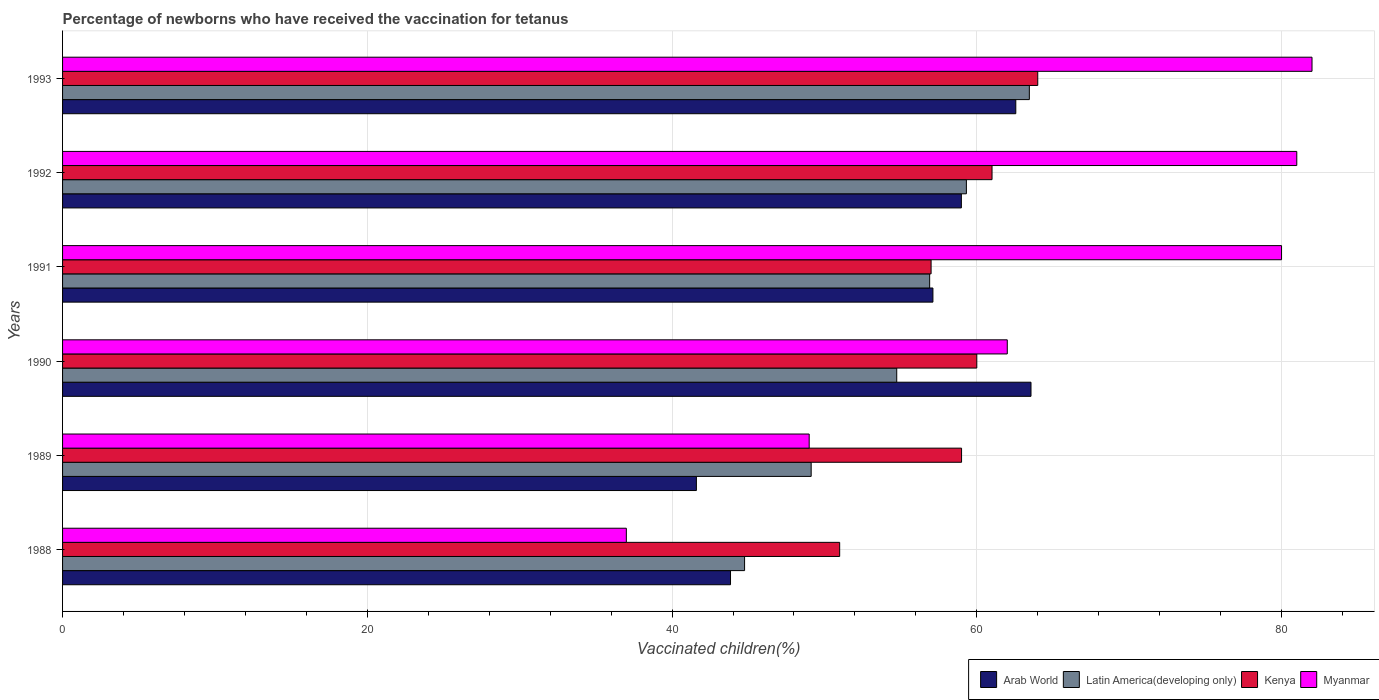How many different coloured bars are there?
Provide a succinct answer. 4. How many groups of bars are there?
Keep it short and to the point. 6. Are the number of bars per tick equal to the number of legend labels?
Offer a very short reply. Yes. Are the number of bars on each tick of the Y-axis equal?
Offer a terse response. Yes. How many bars are there on the 1st tick from the top?
Offer a terse response. 4. What is the label of the 3rd group of bars from the top?
Make the answer very short. 1991. What is the percentage of vaccinated children in Latin America(developing only) in 1988?
Keep it short and to the point. 44.76. Across all years, what is the maximum percentage of vaccinated children in Latin America(developing only)?
Ensure brevity in your answer.  63.45. Across all years, what is the minimum percentage of vaccinated children in Arab World?
Make the answer very short. 41.6. In which year was the percentage of vaccinated children in Kenya maximum?
Offer a very short reply. 1993. What is the total percentage of vaccinated children in Latin America(developing only) in the graph?
Your response must be concise. 328.31. What is the difference between the percentage of vaccinated children in Myanmar in 1988 and that in 1993?
Your answer should be very brief. -45. What is the difference between the percentage of vaccinated children in Myanmar in 1992 and the percentage of vaccinated children in Kenya in 1989?
Provide a short and direct response. 22. What is the average percentage of vaccinated children in Myanmar per year?
Offer a terse response. 65.17. In the year 1991, what is the difference between the percentage of vaccinated children in Latin America(developing only) and percentage of vaccinated children in Kenya?
Offer a very short reply. -0.09. What is the ratio of the percentage of vaccinated children in Latin America(developing only) in 1988 to that in 1989?
Ensure brevity in your answer.  0.91. Is the percentage of vaccinated children in Myanmar in 1990 less than that in 1993?
Your response must be concise. Yes. What is the difference between the highest and the second highest percentage of vaccinated children in Latin America(developing only)?
Provide a succinct answer. 4.13. In how many years, is the percentage of vaccinated children in Arab World greater than the average percentage of vaccinated children in Arab World taken over all years?
Make the answer very short. 4. Is the sum of the percentage of vaccinated children in Kenya in 1988 and 1989 greater than the maximum percentage of vaccinated children in Arab World across all years?
Keep it short and to the point. Yes. What does the 4th bar from the top in 1991 represents?
Provide a short and direct response. Arab World. What does the 4th bar from the bottom in 1989 represents?
Your answer should be compact. Myanmar. Is it the case that in every year, the sum of the percentage of vaccinated children in Arab World and percentage of vaccinated children in Myanmar is greater than the percentage of vaccinated children in Latin America(developing only)?
Give a very brief answer. Yes. Are all the bars in the graph horizontal?
Offer a very short reply. Yes. How many years are there in the graph?
Your answer should be compact. 6. Does the graph contain grids?
Offer a terse response. Yes. Where does the legend appear in the graph?
Give a very brief answer. Bottom right. How many legend labels are there?
Keep it short and to the point. 4. What is the title of the graph?
Keep it short and to the point. Percentage of newborns who have received the vaccination for tetanus. Does "Ghana" appear as one of the legend labels in the graph?
Your answer should be compact. No. What is the label or title of the X-axis?
Offer a terse response. Vaccinated children(%). What is the Vaccinated children(%) in Arab World in 1988?
Offer a very short reply. 43.84. What is the Vaccinated children(%) in Latin America(developing only) in 1988?
Keep it short and to the point. 44.76. What is the Vaccinated children(%) in Arab World in 1989?
Keep it short and to the point. 41.6. What is the Vaccinated children(%) of Latin America(developing only) in 1989?
Keep it short and to the point. 49.13. What is the Vaccinated children(%) of Kenya in 1989?
Your answer should be compact. 59. What is the Vaccinated children(%) in Myanmar in 1989?
Your answer should be very brief. 49. What is the Vaccinated children(%) in Arab World in 1990?
Offer a very short reply. 63.56. What is the Vaccinated children(%) of Latin America(developing only) in 1990?
Make the answer very short. 54.75. What is the Vaccinated children(%) in Kenya in 1990?
Offer a very short reply. 60. What is the Vaccinated children(%) of Arab World in 1991?
Offer a very short reply. 57.12. What is the Vaccinated children(%) of Latin America(developing only) in 1991?
Offer a terse response. 56.91. What is the Vaccinated children(%) of Kenya in 1991?
Your answer should be compact. 57. What is the Vaccinated children(%) in Arab World in 1992?
Offer a very short reply. 58.99. What is the Vaccinated children(%) in Latin America(developing only) in 1992?
Make the answer very short. 59.32. What is the Vaccinated children(%) of Myanmar in 1992?
Ensure brevity in your answer.  81. What is the Vaccinated children(%) in Arab World in 1993?
Give a very brief answer. 62.56. What is the Vaccinated children(%) in Latin America(developing only) in 1993?
Give a very brief answer. 63.45. What is the Vaccinated children(%) in Kenya in 1993?
Your answer should be compact. 64. Across all years, what is the maximum Vaccinated children(%) of Arab World?
Offer a very short reply. 63.56. Across all years, what is the maximum Vaccinated children(%) of Latin America(developing only)?
Your response must be concise. 63.45. Across all years, what is the maximum Vaccinated children(%) of Kenya?
Your response must be concise. 64. Across all years, what is the minimum Vaccinated children(%) in Arab World?
Keep it short and to the point. 41.6. Across all years, what is the minimum Vaccinated children(%) of Latin America(developing only)?
Your answer should be compact. 44.76. What is the total Vaccinated children(%) of Arab World in the graph?
Keep it short and to the point. 327.66. What is the total Vaccinated children(%) in Latin America(developing only) in the graph?
Ensure brevity in your answer.  328.31. What is the total Vaccinated children(%) of Kenya in the graph?
Your response must be concise. 352. What is the total Vaccinated children(%) of Myanmar in the graph?
Offer a very short reply. 391. What is the difference between the Vaccinated children(%) in Arab World in 1988 and that in 1989?
Your response must be concise. 2.24. What is the difference between the Vaccinated children(%) of Latin America(developing only) in 1988 and that in 1989?
Provide a succinct answer. -4.37. What is the difference between the Vaccinated children(%) of Arab World in 1988 and that in 1990?
Your answer should be compact. -19.72. What is the difference between the Vaccinated children(%) in Latin America(developing only) in 1988 and that in 1990?
Your answer should be compact. -9.99. What is the difference between the Vaccinated children(%) in Kenya in 1988 and that in 1990?
Ensure brevity in your answer.  -9. What is the difference between the Vaccinated children(%) in Myanmar in 1988 and that in 1990?
Your answer should be compact. -25. What is the difference between the Vaccinated children(%) of Arab World in 1988 and that in 1991?
Your answer should be very brief. -13.28. What is the difference between the Vaccinated children(%) of Latin America(developing only) in 1988 and that in 1991?
Provide a succinct answer. -12.15. What is the difference between the Vaccinated children(%) of Kenya in 1988 and that in 1991?
Provide a short and direct response. -6. What is the difference between the Vaccinated children(%) in Myanmar in 1988 and that in 1991?
Ensure brevity in your answer.  -43. What is the difference between the Vaccinated children(%) of Arab World in 1988 and that in 1992?
Offer a terse response. -15.15. What is the difference between the Vaccinated children(%) of Latin America(developing only) in 1988 and that in 1992?
Your answer should be very brief. -14.56. What is the difference between the Vaccinated children(%) of Kenya in 1988 and that in 1992?
Keep it short and to the point. -10. What is the difference between the Vaccinated children(%) in Myanmar in 1988 and that in 1992?
Ensure brevity in your answer.  -44. What is the difference between the Vaccinated children(%) in Arab World in 1988 and that in 1993?
Provide a short and direct response. -18.72. What is the difference between the Vaccinated children(%) of Latin America(developing only) in 1988 and that in 1993?
Offer a terse response. -18.69. What is the difference between the Vaccinated children(%) in Kenya in 1988 and that in 1993?
Your response must be concise. -13. What is the difference between the Vaccinated children(%) in Myanmar in 1988 and that in 1993?
Provide a short and direct response. -45. What is the difference between the Vaccinated children(%) in Arab World in 1989 and that in 1990?
Your answer should be compact. -21.96. What is the difference between the Vaccinated children(%) in Latin America(developing only) in 1989 and that in 1990?
Give a very brief answer. -5.62. What is the difference between the Vaccinated children(%) of Myanmar in 1989 and that in 1990?
Your answer should be compact. -13. What is the difference between the Vaccinated children(%) in Arab World in 1989 and that in 1991?
Provide a succinct answer. -15.52. What is the difference between the Vaccinated children(%) in Latin America(developing only) in 1989 and that in 1991?
Ensure brevity in your answer.  -7.78. What is the difference between the Vaccinated children(%) of Kenya in 1989 and that in 1991?
Give a very brief answer. 2. What is the difference between the Vaccinated children(%) in Myanmar in 1989 and that in 1991?
Your response must be concise. -31. What is the difference between the Vaccinated children(%) in Arab World in 1989 and that in 1992?
Your answer should be compact. -17.39. What is the difference between the Vaccinated children(%) in Latin America(developing only) in 1989 and that in 1992?
Your answer should be compact. -10.19. What is the difference between the Vaccinated children(%) in Myanmar in 1989 and that in 1992?
Provide a short and direct response. -32. What is the difference between the Vaccinated children(%) of Arab World in 1989 and that in 1993?
Make the answer very short. -20.96. What is the difference between the Vaccinated children(%) in Latin America(developing only) in 1989 and that in 1993?
Give a very brief answer. -14.32. What is the difference between the Vaccinated children(%) in Kenya in 1989 and that in 1993?
Your response must be concise. -5. What is the difference between the Vaccinated children(%) in Myanmar in 1989 and that in 1993?
Offer a terse response. -33. What is the difference between the Vaccinated children(%) of Arab World in 1990 and that in 1991?
Ensure brevity in your answer.  6.44. What is the difference between the Vaccinated children(%) of Latin America(developing only) in 1990 and that in 1991?
Offer a terse response. -2.16. What is the difference between the Vaccinated children(%) of Kenya in 1990 and that in 1991?
Provide a succinct answer. 3. What is the difference between the Vaccinated children(%) in Arab World in 1990 and that in 1992?
Keep it short and to the point. 4.57. What is the difference between the Vaccinated children(%) in Latin America(developing only) in 1990 and that in 1992?
Provide a succinct answer. -4.57. What is the difference between the Vaccinated children(%) of Kenya in 1990 and that in 1992?
Give a very brief answer. -1. What is the difference between the Vaccinated children(%) in Myanmar in 1990 and that in 1992?
Your answer should be compact. -19. What is the difference between the Vaccinated children(%) in Latin America(developing only) in 1990 and that in 1993?
Provide a short and direct response. -8.7. What is the difference between the Vaccinated children(%) in Arab World in 1991 and that in 1992?
Make the answer very short. -1.87. What is the difference between the Vaccinated children(%) in Latin America(developing only) in 1991 and that in 1992?
Your response must be concise. -2.41. What is the difference between the Vaccinated children(%) of Kenya in 1991 and that in 1992?
Your answer should be compact. -4. What is the difference between the Vaccinated children(%) in Arab World in 1991 and that in 1993?
Your response must be concise. -5.44. What is the difference between the Vaccinated children(%) in Latin America(developing only) in 1991 and that in 1993?
Keep it short and to the point. -6.54. What is the difference between the Vaccinated children(%) in Kenya in 1991 and that in 1993?
Keep it short and to the point. -7. What is the difference between the Vaccinated children(%) of Arab World in 1992 and that in 1993?
Provide a short and direct response. -3.57. What is the difference between the Vaccinated children(%) of Latin America(developing only) in 1992 and that in 1993?
Keep it short and to the point. -4.13. What is the difference between the Vaccinated children(%) in Arab World in 1988 and the Vaccinated children(%) in Latin America(developing only) in 1989?
Your answer should be compact. -5.29. What is the difference between the Vaccinated children(%) of Arab World in 1988 and the Vaccinated children(%) of Kenya in 1989?
Offer a very short reply. -15.16. What is the difference between the Vaccinated children(%) of Arab World in 1988 and the Vaccinated children(%) of Myanmar in 1989?
Keep it short and to the point. -5.16. What is the difference between the Vaccinated children(%) in Latin America(developing only) in 1988 and the Vaccinated children(%) in Kenya in 1989?
Your answer should be very brief. -14.24. What is the difference between the Vaccinated children(%) in Latin America(developing only) in 1988 and the Vaccinated children(%) in Myanmar in 1989?
Offer a very short reply. -4.24. What is the difference between the Vaccinated children(%) in Arab World in 1988 and the Vaccinated children(%) in Latin America(developing only) in 1990?
Your answer should be compact. -10.91. What is the difference between the Vaccinated children(%) in Arab World in 1988 and the Vaccinated children(%) in Kenya in 1990?
Provide a succinct answer. -16.16. What is the difference between the Vaccinated children(%) of Arab World in 1988 and the Vaccinated children(%) of Myanmar in 1990?
Your answer should be very brief. -18.16. What is the difference between the Vaccinated children(%) of Latin America(developing only) in 1988 and the Vaccinated children(%) of Kenya in 1990?
Give a very brief answer. -15.24. What is the difference between the Vaccinated children(%) of Latin America(developing only) in 1988 and the Vaccinated children(%) of Myanmar in 1990?
Offer a very short reply. -17.24. What is the difference between the Vaccinated children(%) in Kenya in 1988 and the Vaccinated children(%) in Myanmar in 1990?
Your answer should be compact. -11. What is the difference between the Vaccinated children(%) in Arab World in 1988 and the Vaccinated children(%) in Latin America(developing only) in 1991?
Provide a succinct answer. -13.07. What is the difference between the Vaccinated children(%) in Arab World in 1988 and the Vaccinated children(%) in Kenya in 1991?
Offer a terse response. -13.16. What is the difference between the Vaccinated children(%) of Arab World in 1988 and the Vaccinated children(%) of Myanmar in 1991?
Provide a succinct answer. -36.16. What is the difference between the Vaccinated children(%) of Latin America(developing only) in 1988 and the Vaccinated children(%) of Kenya in 1991?
Ensure brevity in your answer.  -12.24. What is the difference between the Vaccinated children(%) in Latin America(developing only) in 1988 and the Vaccinated children(%) in Myanmar in 1991?
Ensure brevity in your answer.  -35.24. What is the difference between the Vaccinated children(%) in Kenya in 1988 and the Vaccinated children(%) in Myanmar in 1991?
Your response must be concise. -29. What is the difference between the Vaccinated children(%) in Arab World in 1988 and the Vaccinated children(%) in Latin America(developing only) in 1992?
Give a very brief answer. -15.48. What is the difference between the Vaccinated children(%) in Arab World in 1988 and the Vaccinated children(%) in Kenya in 1992?
Provide a succinct answer. -17.16. What is the difference between the Vaccinated children(%) in Arab World in 1988 and the Vaccinated children(%) in Myanmar in 1992?
Offer a terse response. -37.16. What is the difference between the Vaccinated children(%) in Latin America(developing only) in 1988 and the Vaccinated children(%) in Kenya in 1992?
Your answer should be very brief. -16.24. What is the difference between the Vaccinated children(%) in Latin America(developing only) in 1988 and the Vaccinated children(%) in Myanmar in 1992?
Keep it short and to the point. -36.24. What is the difference between the Vaccinated children(%) in Arab World in 1988 and the Vaccinated children(%) in Latin America(developing only) in 1993?
Make the answer very short. -19.61. What is the difference between the Vaccinated children(%) in Arab World in 1988 and the Vaccinated children(%) in Kenya in 1993?
Offer a very short reply. -20.16. What is the difference between the Vaccinated children(%) of Arab World in 1988 and the Vaccinated children(%) of Myanmar in 1993?
Make the answer very short. -38.16. What is the difference between the Vaccinated children(%) of Latin America(developing only) in 1988 and the Vaccinated children(%) of Kenya in 1993?
Make the answer very short. -19.24. What is the difference between the Vaccinated children(%) in Latin America(developing only) in 1988 and the Vaccinated children(%) in Myanmar in 1993?
Provide a succinct answer. -37.24. What is the difference between the Vaccinated children(%) in Kenya in 1988 and the Vaccinated children(%) in Myanmar in 1993?
Give a very brief answer. -31. What is the difference between the Vaccinated children(%) in Arab World in 1989 and the Vaccinated children(%) in Latin America(developing only) in 1990?
Your response must be concise. -13.15. What is the difference between the Vaccinated children(%) of Arab World in 1989 and the Vaccinated children(%) of Kenya in 1990?
Keep it short and to the point. -18.4. What is the difference between the Vaccinated children(%) in Arab World in 1989 and the Vaccinated children(%) in Myanmar in 1990?
Offer a terse response. -20.4. What is the difference between the Vaccinated children(%) of Latin America(developing only) in 1989 and the Vaccinated children(%) of Kenya in 1990?
Offer a terse response. -10.87. What is the difference between the Vaccinated children(%) of Latin America(developing only) in 1989 and the Vaccinated children(%) of Myanmar in 1990?
Offer a terse response. -12.87. What is the difference between the Vaccinated children(%) in Kenya in 1989 and the Vaccinated children(%) in Myanmar in 1990?
Give a very brief answer. -3. What is the difference between the Vaccinated children(%) in Arab World in 1989 and the Vaccinated children(%) in Latin America(developing only) in 1991?
Your answer should be compact. -15.31. What is the difference between the Vaccinated children(%) in Arab World in 1989 and the Vaccinated children(%) in Kenya in 1991?
Your response must be concise. -15.4. What is the difference between the Vaccinated children(%) of Arab World in 1989 and the Vaccinated children(%) of Myanmar in 1991?
Keep it short and to the point. -38.4. What is the difference between the Vaccinated children(%) of Latin America(developing only) in 1989 and the Vaccinated children(%) of Kenya in 1991?
Offer a very short reply. -7.87. What is the difference between the Vaccinated children(%) of Latin America(developing only) in 1989 and the Vaccinated children(%) of Myanmar in 1991?
Your answer should be compact. -30.87. What is the difference between the Vaccinated children(%) in Kenya in 1989 and the Vaccinated children(%) in Myanmar in 1991?
Your answer should be very brief. -21. What is the difference between the Vaccinated children(%) of Arab World in 1989 and the Vaccinated children(%) of Latin America(developing only) in 1992?
Your response must be concise. -17.72. What is the difference between the Vaccinated children(%) of Arab World in 1989 and the Vaccinated children(%) of Kenya in 1992?
Offer a terse response. -19.4. What is the difference between the Vaccinated children(%) of Arab World in 1989 and the Vaccinated children(%) of Myanmar in 1992?
Make the answer very short. -39.4. What is the difference between the Vaccinated children(%) in Latin America(developing only) in 1989 and the Vaccinated children(%) in Kenya in 1992?
Ensure brevity in your answer.  -11.87. What is the difference between the Vaccinated children(%) of Latin America(developing only) in 1989 and the Vaccinated children(%) of Myanmar in 1992?
Make the answer very short. -31.87. What is the difference between the Vaccinated children(%) of Arab World in 1989 and the Vaccinated children(%) of Latin America(developing only) in 1993?
Provide a succinct answer. -21.85. What is the difference between the Vaccinated children(%) of Arab World in 1989 and the Vaccinated children(%) of Kenya in 1993?
Your answer should be very brief. -22.4. What is the difference between the Vaccinated children(%) of Arab World in 1989 and the Vaccinated children(%) of Myanmar in 1993?
Your answer should be very brief. -40.4. What is the difference between the Vaccinated children(%) in Latin America(developing only) in 1989 and the Vaccinated children(%) in Kenya in 1993?
Ensure brevity in your answer.  -14.87. What is the difference between the Vaccinated children(%) of Latin America(developing only) in 1989 and the Vaccinated children(%) of Myanmar in 1993?
Offer a very short reply. -32.87. What is the difference between the Vaccinated children(%) of Kenya in 1989 and the Vaccinated children(%) of Myanmar in 1993?
Offer a terse response. -23. What is the difference between the Vaccinated children(%) in Arab World in 1990 and the Vaccinated children(%) in Latin America(developing only) in 1991?
Provide a short and direct response. 6.65. What is the difference between the Vaccinated children(%) in Arab World in 1990 and the Vaccinated children(%) in Kenya in 1991?
Provide a short and direct response. 6.56. What is the difference between the Vaccinated children(%) in Arab World in 1990 and the Vaccinated children(%) in Myanmar in 1991?
Make the answer very short. -16.44. What is the difference between the Vaccinated children(%) of Latin America(developing only) in 1990 and the Vaccinated children(%) of Kenya in 1991?
Provide a succinct answer. -2.25. What is the difference between the Vaccinated children(%) in Latin America(developing only) in 1990 and the Vaccinated children(%) in Myanmar in 1991?
Your answer should be compact. -25.25. What is the difference between the Vaccinated children(%) in Arab World in 1990 and the Vaccinated children(%) in Latin America(developing only) in 1992?
Your response must be concise. 4.24. What is the difference between the Vaccinated children(%) in Arab World in 1990 and the Vaccinated children(%) in Kenya in 1992?
Your response must be concise. 2.56. What is the difference between the Vaccinated children(%) of Arab World in 1990 and the Vaccinated children(%) of Myanmar in 1992?
Keep it short and to the point. -17.44. What is the difference between the Vaccinated children(%) of Latin America(developing only) in 1990 and the Vaccinated children(%) of Kenya in 1992?
Offer a terse response. -6.25. What is the difference between the Vaccinated children(%) of Latin America(developing only) in 1990 and the Vaccinated children(%) of Myanmar in 1992?
Keep it short and to the point. -26.25. What is the difference between the Vaccinated children(%) of Arab World in 1990 and the Vaccinated children(%) of Latin America(developing only) in 1993?
Provide a short and direct response. 0.11. What is the difference between the Vaccinated children(%) in Arab World in 1990 and the Vaccinated children(%) in Kenya in 1993?
Make the answer very short. -0.44. What is the difference between the Vaccinated children(%) of Arab World in 1990 and the Vaccinated children(%) of Myanmar in 1993?
Make the answer very short. -18.44. What is the difference between the Vaccinated children(%) in Latin America(developing only) in 1990 and the Vaccinated children(%) in Kenya in 1993?
Make the answer very short. -9.25. What is the difference between the Vaccinated children(%) of Latin America(developing only) in 1990 and the Vaccinated children(%) of Myanmar in 1993?
Make the answer very short. -27.25. What is the difference between the Vaccinated children(%) of Kenya in 1990 and the Vaccinated children(%) of Myanmar in 1993?
Offer a terse response. -22. What is the difference between the Vaccinated children(%) in Arab World in 1991 and the Vaccinated children(%) in Latin America(developing only) in 1992?
Offer a very short reply. -2.2. What is the difference between the Vaccinated children(%) in Arab World in 1991 and the Vaccinated children(%) in Kenya in 1992?
Make the answer very short. -3.88. What is the difference between the Vaccinated children(%) in Arab World in 1991 and the Vaccinated children(%) in Myanmar in 1992?
Your answer should be compact. -23.88. What is the difference between the Vaccinated children(%) in Latin America(developing only) in 1991 and the Vaccinated children(%) in Kenya in 1992?
Your answer should be very brief. -4.09. What is the difference between the Vaccinated children(%) of Latin America(developing only) in 1991 and the Vaccinated children(%) of Myanmar in 1992?
Offer a very short reply. -24.09. What is the difference between the Vaccinated children(%) in Kenya in 1991 and the Vaccinated children(%) in Myanmar in 1992?
Ensure brevity in your answer.  -24. What is the difference between the Vaccinated children(%) of Arab World in 1991 and the Vaccinated children(%) of Latin America(developing only) in 1993?
Ensure brevity in your answer.  -6.33. What is the difference between the Vaccinated children(%) in Arab World in 1991 and the Vaccinated children(%) in Kenya in 1993?
Ensure brevity in your answer.  -6.88. What is the difference between the Vaccinated children(%) in Arab World in 1991 and the Vaccinated children(%) in Myanmar in 1993?
Keep it short and to the point. -24.88. What is the difference between the Vaccinated children(%) of Latin America(developing only) in 1991 and the Vaccinated children(%) of Kenya in 1993?
Offer a very short reply. -7.09. What is the difference between the Vaccinated children(%) of Latin America(developing only) in 1991 and the Vaccinated children(%) of Myanmar in 1993?
Your answer should be very brief. -25.09. What is the difference between the Vaccinated children(%) of Kenya in 1991 and the Vaccinated children(%) of Myanmar in 1993?
Your answer should be very brief. -25. What is the difference between the Vaccinated children(%) in Arab World in 1992 and the Vaccinated children(%) in Latin America(developing only) in 1993?
Your answer should be compact. -4.46. What is the difference between the Vaccinated children(%) of Arab World in 1992 and the Vaccinated children(%) of Kenya in 1993?
Your answer should be compact. -5.01. What is the difference between the Vaccinated children(%) of Arab World in 1992 and the Vaccinated children(%) of Myanmar in 1993?
Your response must be concise. -23.01. What is the difference between the Vaccinated children(%) in Latin America(developing only) in 1992 and the Vaccinated children(%) in Kenya in 1993?
Ensure brevity in your answer.  -4.68. What is the difference between the Vaccinated children(%) of Latin America(developing only) in 1992 and the Vaccinated children(%) of Myanmar in 1993?
Offer a very short reply. -22.68. What is the difference between the Vaccinated children(%) in Kenya in 1992 and the Vaccinated children(%) in Myanmar in 1993?
Your response must be concise. -21. What is the average Vaccinated children(%) of Arab World per year?
Keep it short and to the point. 54.61. What is the average Vaccinated children(%) in Latin America(developing only) per year?
Make the answer very short. 54.72. What is the average Vaccinated children(%) in Kenya per year?
Keep it short and to the point. 58.67. What is the average Vaccinated children(%) in Myanmar per year?
Make the answer very short. 65.17. In the year 1988, what is the difference between the Vaccinated children(%) in Arab World and Vaccinated children(%) in Latin America(developing only)?
Make the answer very short. -0.92. In the year 1988, what is the difference between the Vaccinated children(%) in Arab World and Vaccinated children(%) in Kenya?
Ensure brevity in your answer.  -7.16. In the year 1988, what is the difference between the Vaccinated children(%) of Arab World and Vaccinated children(%) of Myanmar?
Ensure brevity in your answer.  6.84. In the year 1988, what is the difference between the Vaccinated children(%) in Latin America(developing only) and Vaccinated children(%) in Kenya?
Ensure brevity in your answer.  -6.24. In the year 1988, what is the difference between the Vaccinated children(%) of Latin America(developing only) and Vaccinated children(%) of Myanmar?
Offer a terse response. 7.76. In the year 1989, what is the difference between the Vaccinated children(%) of Arab World and Vaccinated children(%) of Latin America(developing only)?
Give a very brief answer. -7.53. In the year 1989, what is the difference between the Vaccinated children(%) of Arab World and Vaccinated children(%) of Kenya?
Your response must be concise. -17.4. In the year 1989, what is the difference between the Vaccinated children(%) of Arab World and Vaccinated children(%) of Myanmar?
Keep it short and to the point. -7.4. In the year 1989, what is the difference between the Vaccinated children(%) in Latin America(developing only) and Vaccinated children(%) in Kenya?
Your answer should be very brief. -9.87. In the year 1989, what is the difference between the Vaccinated children(%) in Latin America(developing only) and Vaccinated children(%) in Myanmar?
Give a very brief answer. 0.13. In the year 1989, what is the difference between the Vaccinated children(%) in Kenya and Vaccinated children(%) in Myanmar?
Your answer should be compact. 10. In the year 1990, what is the difference between the Vaccinated children(%) of Arab World and Vaccinated children(%) of Latin America(developing only)?
Provide a succinct answer. 8.81. In the year 1990, what is the difference between the Vaccinated children(%) of Arab World and Vaccinated children(%) of Kenya?
Offer a terse response. 3.56. In the year 1990, what is the difference between the Vaccinated children(%) in Arab World and Vaccinated children(%) in Myanmar?
Your answer should be compact. 1.56. In the year 1990, what is the difference between the Vaccinated children(%) of Latin America(developing only) and Vaccinated children(%) of Kenya?
Give a very brief answer. -5.25. In the year 1990, what is the difference between the Vaccinated children(%) of Latin America(developing only) and Vaccinated children(%) of Myanmar?
Give a very brief answer. -7.25. In the year 1991, what is the difference between the Vaccinated children(%) in Arab World and Vaccinated children(%) in Latin America(developing only)?
Give a very brief answer. 0.21. In the year 1991, what is the difference between the Vaccinated children(%) of Arab World and Vaccinated children(%) of Kenya?
Offer a very short reply. 0.12. In the year 1991, what is the difference between the Vaccinated children(%) of Arab World and Vaccinated children(%) of Myanmar?
Provide a succinct answer. -22.88. In the year 1991, what is the difference between the Vaccinated children(%) of Latin America(developing only) and Vaccinated children(%) of Kenya?
Ensure brevity in your answer.  -0.09. In the year 1991, what is the difference between the Vaccinated children(%) in Latin America(developing only) and Vaccinated children(%) in Myanmar?
Give a very brief answer. -23.09. In the year 1991, what is the difference between the Vaccinated children(%) in Kenya and Vaccinated children(%) in Myanmar?
Provide a short and direct response. -23. In the year 1992, what is the difference between the Vaccinated children(%) of Arab World and Vaccinated children(%) of Latin America(developing only)?
Make the answer very short. -0.33. In the year 1992, what is the difference between the Vaccinated children(%) in Arab World and Vaccinated children(%) in Kenya?
Provide a succinct answer. -2.01. In the year 1992, what is the difference between the Vaccinated children(%) of Arab World and Vaccinated children(%) of Myanmar?
Offer a terse response. -22.01. In the year 1992, what is the difference between the Vaccinated children(%) of Latin America(developing only) and Vaccinated children(%) of Kenya?
Make the answer very short. -1.68. In the year 1992, what is the difference between the Vaccinated children(%) in Latin America(developing only) and Vaccinated children(%) in Myanmar?
Offer a terse response. -21.68. In the year 1992, what is the difference between the Vaccinated children(%) of Kenya and Vaccinated children(%) of Myanmar?
Provide a short and direct response. -20. In the year 1993, what is the difference between the Vaccinated children(%) of Arab World and Vaccinated children(%) of Latin America(developing only)?
Your answer should be very brief. -0.89. In the year 1993, what is the difference between the Vaccinated children(%) of Arab World and Vaccinated children(%) of Kenya?
Your response must be concise. -1.44. In the year 1993, what is the difference between the Vaccinated children(%) of Arab World and Vaccinated children(%) of Myanmar?
Provide a succinct answer. -19.44. In the year 1993, what is the difference between the Vaccinated children(%) in Latin America(developing only) and Vaccinated children(%) in Kenya?
Give a very brief answer. -0.55. In the year 1993, what is the difference between the Vaccinated children(%) of Latin America(developing only) and Vaccinated children(%) of Myanmar?
Provide a succinct answer. -18.55. In the year 1993, what is the difference between the Vaccinated children(%) of Kenya and Vaccinated children(%) of Myanmar?
Offer a very short reply. -18. What is the ratio of the Vaccinated children(%) of Arab World in 1988 to that in 1989?
Your response must be concise. 1.05. What is the ratio of the Vaccinated children(%) of Latin America(developing only) in 1988 to that in 1989?
Your response must be concise. 0.91. What is the ratio of the Vaccinated children(%) in Kenya in 1988 to that in 1989?
Make the answer very short. 0.86. What is the ratio of the Vaccinated children(%) in Myanmar in 1988 to that in 1989?
Your answer should be compact. 0.76. What is the ratio of the Vaccinated children(%) of Arab World in 1988 to that in 1990?
Your answer should be very brief. 0.69. What is the ratio of the Vaccinated children(%) of Latin America(developing only) in 1988 to that in 1990?
Offer a terse response. 0.82. What is the ratio of the Vaccinated children(%) of Myanmar in 1988 to that in 1990?
Ensure brevity in your answer.  0.6. What is the ratio of the Vaccinated children(%) of Arab World in 1988 to that in 1991?
Your answer should be compact. 0.77. What is the ratio of the Vaccinated children(%) of Latin America(developing only) in 1988 to that in 1991?
Ensure brevity in your answer.  0.79. What is the ratio of the Vaccinated children(%) in Kenya in 1988 to that in 1991?
Your response must be concise. 0.89. What is the ratio of the Vaccinated children(%) of Myanmar in 1988 to that in 1991?
Ensure brevity in your answer.  0.46. What is the ratio of the Vaccinated children(%) of Arab World in 1988 to that in 1992?
Provide a succinct answer. 0.74. What is the ratio of the Vaccinated children(%) of Latin America(developing only) in 1988 to that in 1992?
Provide a succinct answer. 0.75. What is the ratio of the Vaccinated children(%) in Kenya in 1988 to that in 1992?
Offer a very short reply. 0.84. What is the ratio of the Vaccinated children(%) in Myanmar in 1988 to that in 1992?
Ensure brevity in your answer.  0.46. What is the ratio of the Vaccinated children(%) in Arab World in 1988 to that in 1993?
Your answer should be very brief. 0.7. What is the ratio of the Vaccinated children(%) in Latin America(developing only) in 1988 to that in 1993?
Your answer should be very brief. 0.71. What is the ratio of the Vaccinated children(%) in Kenya in 1988 to that in 1993?
Give a very brief answer. 0.8. What is the ratio of the Vaccinated children(%) of Myanmar in 1988 to that in 1993?
Provide a succinct answer. 0.45. What is the ratio of the Vaccinated children(%) in Arab World in 1989 to that in 1990?
Your response must be concise. 0.65. What is the ratio of the Vaccinated children(%) in Latin America(developing only) in 1989 to that in 1990?
Keep it short and to the point. 0.9. What is the ratio of the Vaccinated children(%) in Kenya in 1989 to that in 1990?
Your answer should be compact. 0.98. What is the ratio of the Vaccinated children(%) in Myanmar in 1989 to that in 1990?
Offer a terse response. 0.79. What is the ratio of the Vaccinated children(%) of Arab World in 1989 to that in 1991?
Offer a very short reply. 0.73. What is the ratio of the Vaccinated children(%) in Latin America(developing only) in 1989 to that in 1991?
Make the answer very short. 0.86. What is the ratio of the Vaccinated children(%) of Kenya in 1989 to that in 1991?
Provide a short and direct response. 1.04. What is the ratio of the Vaccinated children(%) of Myanmar in 1989 to that in 1991?
Give a very brief answer. 0.61. What is the ratio of the Vaccinated children(%) of Arab World in 1989 to that in 1992?
Provide a succinct answer. 0.71. What is the ratio of the Vaccinated children(%) of Latin America(developing only) in 1989 to that in 1992?
Keep it short and to the point. 0.83. What is the ratio of the Vaccinated children(%) in Kenya in 1989 to that in 1992?
Your response must be concise. 0.97. What is the ratio of the Vaccinated children(%) in Myanmar in 1989 to that in 1992?
Your response must be concise. 0.6. What is the ratio of the Vaccinated children(%) in Arab World in 1989 to that in 1993?
Your answer should be very brief. 0.66. What is the ratio of the Vaccinated children(%) in Latin America(developing only) in 1989 to that in 1993?
Offer a very short reply. 0.77. What is the ratio of the Vaccinated children(%) of Kenya in 1989 to that in 1993?
Offer a terse response. 0.92. What is the ratio of the Vaccinated children(%) of Myanmar in 1989 to that in 1993?
Ensure brevity in your answer.  0.6. What is the ratio of the Vaccinated children(%) in Arab World in 1990 to that in 1991?
Offer a terse response. 1.11. What is the ratio of the Vaccinated children(%) in Kenya in 1990 to that in 1991?
Provide a short and direct response. 1.05. What is the ratio of the Vaccinated children(%) of Myanmar in 1990 to that in 1991?
Your response must be concise. 0.78. What is the ratio of the Vaccinated children(%) in Arab World in 1990 to that in 1992?
Your answer should be compact. 1.08. What is the ratio of the Vaccinated children(%) in Latin America(developing only) in 1990 to that in 1992?
Your answer should be very brief. 0.92. What is the ratio of the Vaccinated children(%) of Kenya in 1990 to that in 1992?
Offer a very short reply. 0.98. What is the ratio of the Vaccinated children(%) in Myanmar in 1990 to that in 1992?
Your answer should be compact. 0.77. What is the ratio of the Vaccinated children(%) in Arab World in 1990 to that in 1993?
Make the answer very short. 1.02. What is the ratio of the Vaccinated children(%) in Latin America(developing only) in 1990 to that in 1993?
Offer a very short reply. 0.86. What is the ratio of the Vaccinated children(%) of Myanmar in 1990 to that in 1993?
Your answer should be very brief. 0.76. What is the ratio of the Vaccinated children(%) of Arab World in 1991 to that in 1992?
Provide a short and direct response. 0.97. What is the ratio of the Vaccinated children(%) in Latin America(developing only) in 1991 to that in 1992?
Give a very brief answer. 0.96. What is the ratio of the Vaccinated children(%) of Kenya in 1991 to that in 1992?
Offer a terse response. 0.93. What is the ratio of the Vaccinated children(%) of Myanmar in 1991 to that in 1992?
Keep it short and to the point. 0.99. What is the ratio of the Vaccinated children(%) in Arab World in 1991 to that in 1993?
Provide a succinct answer. 0.91. What is the ratio of the Vaccinated children(%) of Latin America(developing only) in 1991 to that in 1993?
Make the answer very short. 0.9. What is the ratio of the Vaccinated children(%) in Kenya in 1991 to that in 1993?
Provide a succinct answer. 0.89. What is the ratio of the Vaccinated children(%) in Myanmar in 1991 to that in 1993?
Give a very brief answer. 0.98. What is the ratio of the Vaccinated children(%) of Arab World in 1992 to that in 1993?
Make the answer very short. 0.94. What is the ratio of the Vaccinated children(%) in Latin America(developing only) in 1992 to that in 1993?
Keep it short and to the point. 0.93. What is the ratio of the Vaccinated children(%) of Kenya in 1992 to that in 1993?
Your answer should be compact. 0.95. What is the ratio of the Vaccinated children(%) of Myanmar in 1992 to that in 1993?
Keep it short and to the point. 0.99. What is the difference between the highest and the second highest Vaccinated children(%) in Arab World?
Your response must be concise. 1. What is the difference between the highest and the second highest Vaccinated children(%) in Latin America(developing only)?
Your answer should be very brief. 4.13. What is the difference between the highest and the lowest Vaccinated children(%) of Arab World?
Your answer should be compact. 21.96. What is the difference between the highest and the lowest Vaccinated children(%) of Latin America(developing only)?
Ensure brevity in your answer.  18.69. 